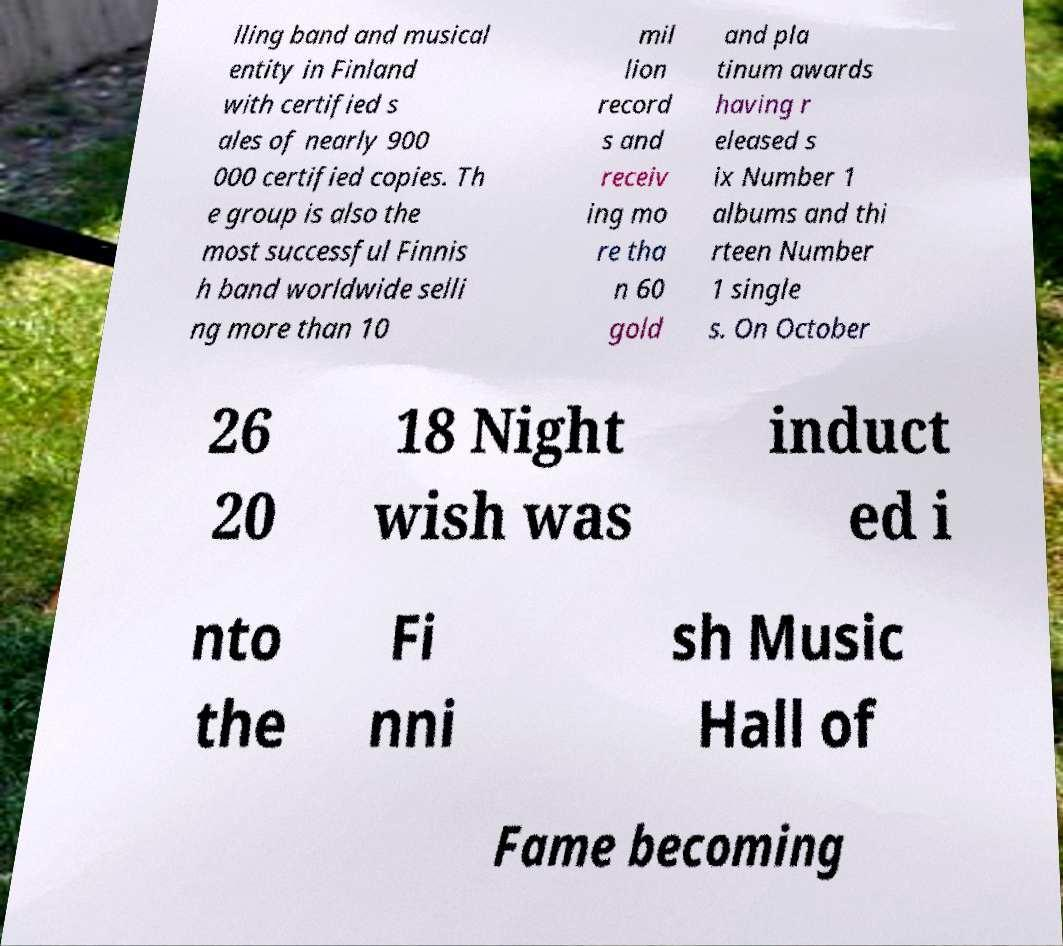What messages or text are displayed in this image? I need them in a readable, typed format. lling band and musical entity in Finland with certified s ales of nearly 900 000 certified copies. Th e group is also the most successful Finnis h band worldwide selli ng more than 10 mil lion record s and receiv ing mo re tha n 60 gold and pla tinum awards having r eleased s ix Number 1 albums and thi rteen Number 1 single s. On October 26 20 18 Night wish was induct ed i nto the Fi nni sh Music Hall of Fame becoming 